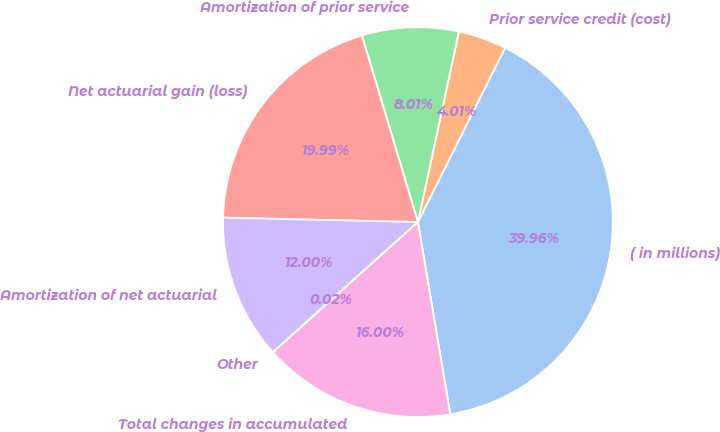<chart> <loc_0><loc_0><loc_500><loc_500><pie_chart><fcel>( in millions)<fcel>Prior service credit (cost)<fcel>Amortization of prior service<fcel>Net actuarial gain (loss)<fcel>Amortization of net actuarial<fcel>Other<fcel>Total changes in accumulated<nl><fcel>39.96%<fcel>4.01%<fcel>8.01%<fcel>19.99%<fcel>12.0%<fcel>0.02%<fcel>16.0%<nl></chart> 